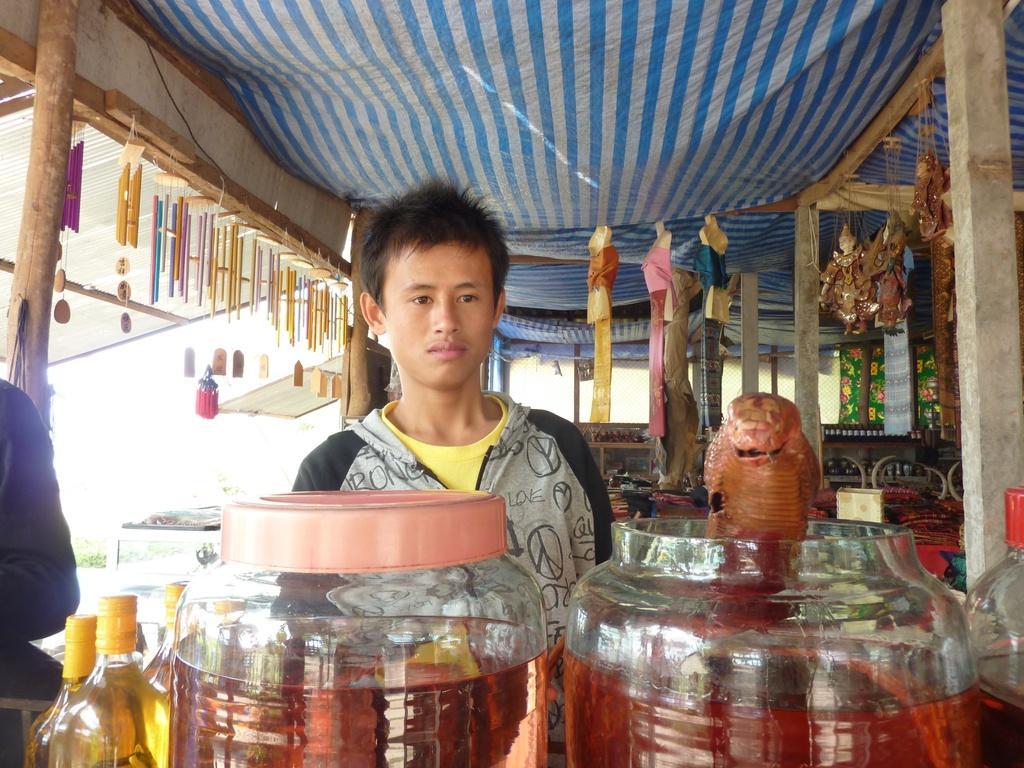Please provide a concise description of this image. In this image in front there are jars, bottles and there is a person standing under the tent. 